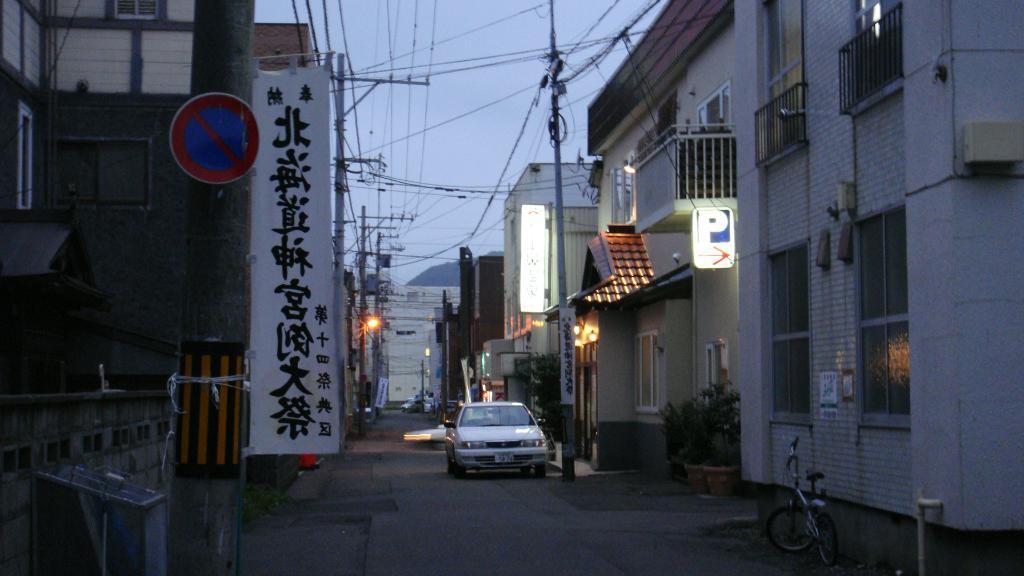Describe this image in one or two sentences. In this image we can see few houses, there are windows, grilles, plants, electric poles, wires, there is a car, and a bicycle on the road, there is a board with text on it, there is a sign board, there is a box, and a poster with some text on it, also we can see the sky. 